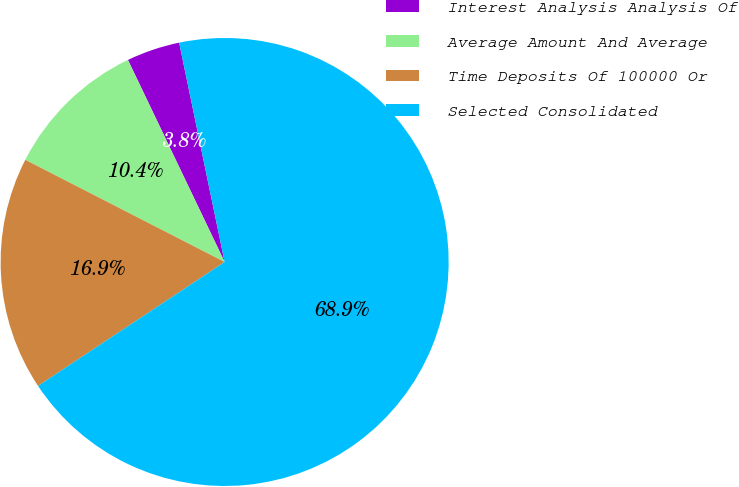Convert chart to OTSL. <chart><loc_0><loc_0><loc_500><loc_500><pie_chart><fcel>Interest Analysis Analysis Of<fcel>Average Amount And Average<fcel>Time Deposits Of 100000 Or<fcel>Selected Consolidated<nl><fcel>3.85%<fcel>10.36%<fcel>16.87%<fcel>68.93%<nl></chart> 